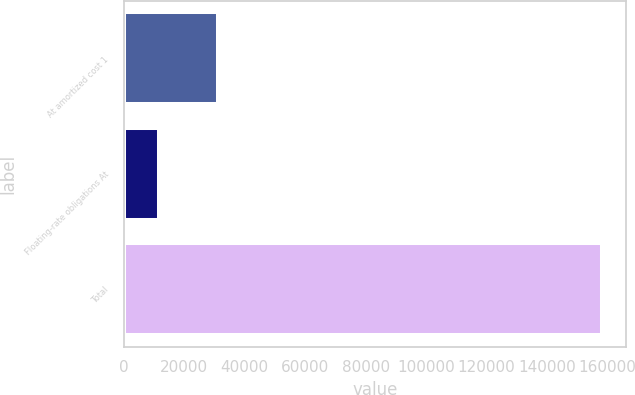<chart> <loc_0><loc_0><loc_500><loc_500><bar_chart><fcel>At amortized cost 1<fcel>Floating-rate obligations At<fcel>Total<nl><fcel>31232<fcel>11662<fcel>158311<nl></chart> 